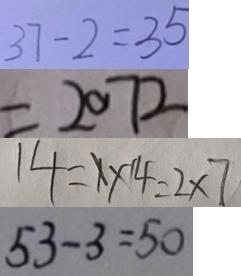Convert formula to latex. <formula><loc_0><loc_0><loc_500><loc_500>3 7 - 2 = 3 5 
 = 2 0 7 2 
 1 4 = 1 \times 1 4 = 2 \times 7 
 5 3 - 3 = 5 0</formula> 